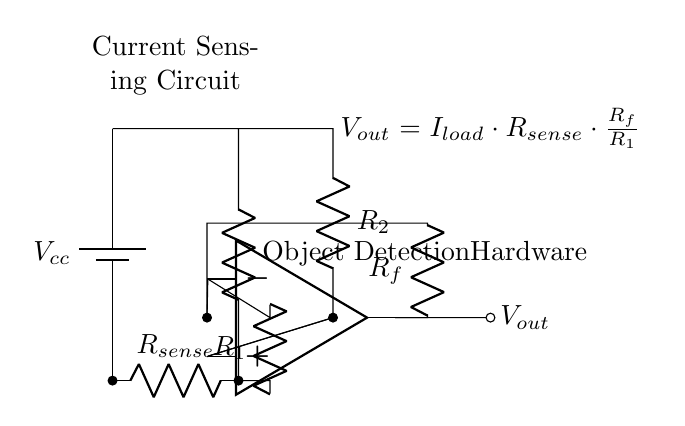What is the purpose of the current sense resistor? The current sense resistor is used to measure the current flowing through the object detection hardware. By placing it in series with the load, the voltage across this resistor can be used to determine the load current through Ohm's law.
Answer: Current measurement What is the output voltage formula of the differential amplifier? The output voltage formula shown in the circuit is derived from the relationship between the input voltage and the feedback, which is expressed as \( V_{out} = I_{load} \cdot R_{sense} \cdot \frac{R_f}{R_1} \). This captures how the load current influences the output.
Answer: I load multiplied by R sense multiplied by R f divided by R 1 How many resistors are present in this circuit? The circuit includes four resistors: R sense, R 1, R 2, and R f. Each plays a key role in both the current sensing and the gain of the differential amplifier.
Answer: Four resistors What type of amplifier is used in the circuit? The circuit employs a differential amplifier, which is designed to amplify the difference between two input signals while rejecting common-mode signals, making it ideal for accurate current sensing.
Answer: Differential amplifier What is the role of the feedback resistor in the circuit? The feedback resistor (R f) provides the necessary feedback to the differential amplifier, allowing it to control the gain of the output voltage. The ratio of R f to R 1 affects how much the input signal is amplified.
Answer: Gain control Which component generates the input current for the sensing circuit? The object detection hardware generates the input current as it operates. This current flows through the current sense resistor, allowing for the voltage to be measured and thus the current calculated.
Answer: Object detection hardware 